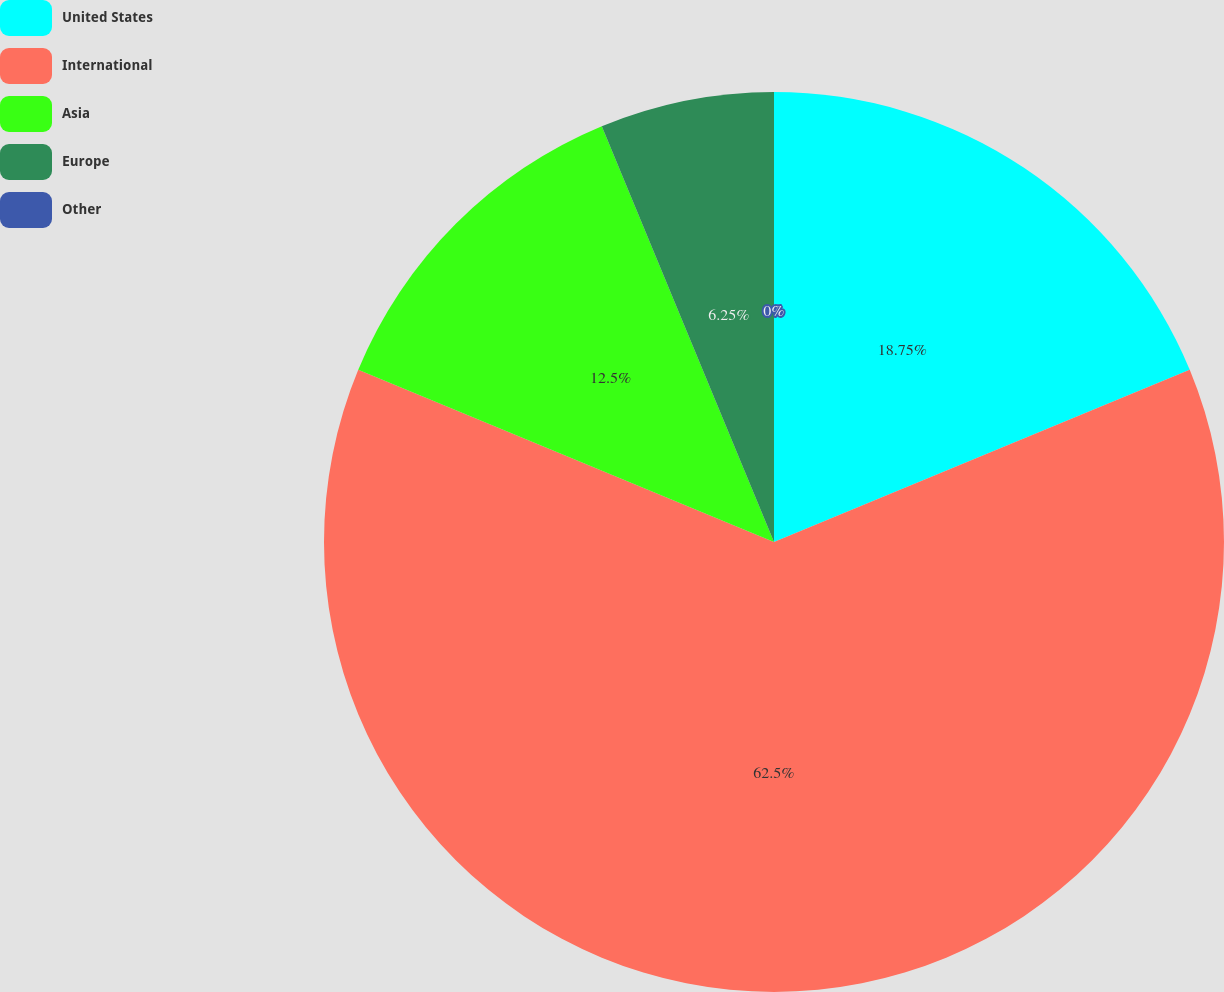Convert chart to OTSL. <chart><loc_0><loc_0><loc_500><loc_500><pie_chart><fcel>United States<fcel>International<fcel>Asia<fcel>Europe<fcel>Other<nl><fcel>18.75%<fcel>62.5%<fcel>12.5%<fcel>6.25%<fcel>0.0%<nl></chart> 